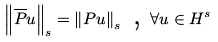Convert formula to latex. <formula><loc_0><loc_0><loc_500><loc_500>\left \| \overline { P } u \right \| _ { s } = \left \| P u \right \| _ { s } \text { , } \forall u \in H ^ { s }</formula> 